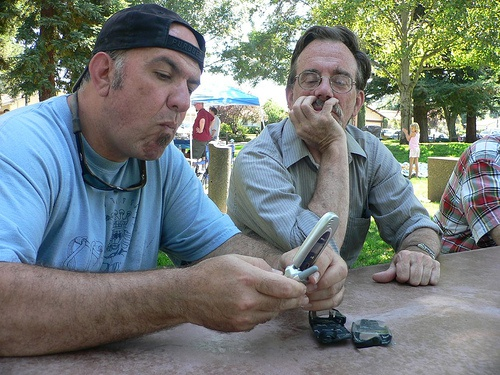Describe the objects in this image and their specific colors. I can see people in black, gray, and lightblue tones, dining table in black and gray tones, people in black, gray, and darkgray tones, people in black, gray, darkgray, and maroon tones, and cell phone in black, gray, darkgray, and lightblue tones in this image. 